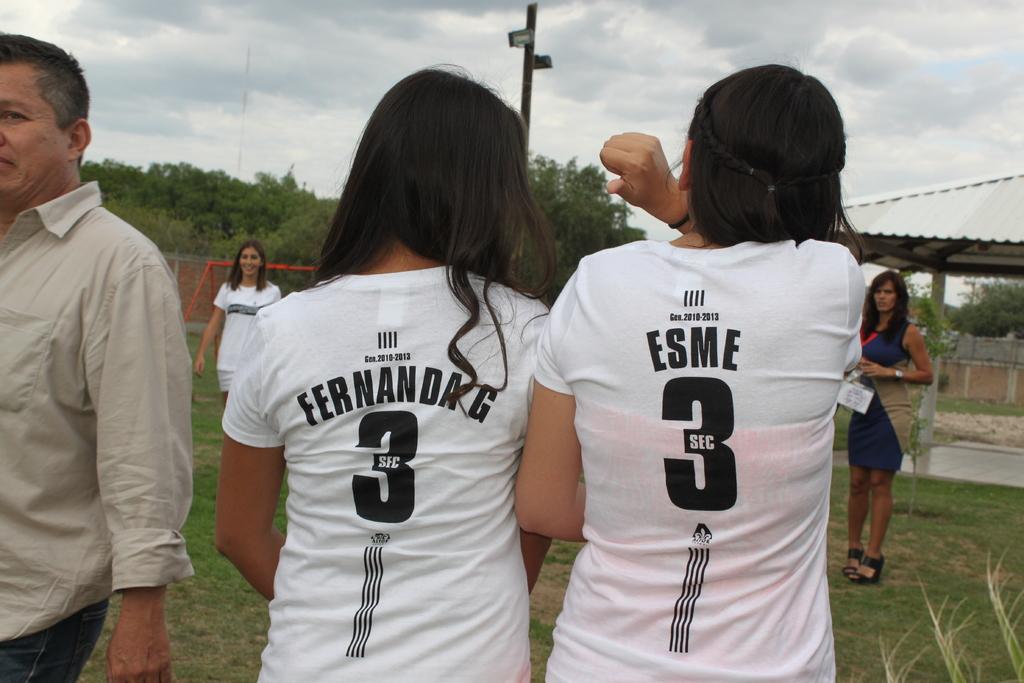Who are the two players?
Offer a terse response. Fernanda g and esme. What number do they both have on their shirts?
Keep it short and to the point. 3. 